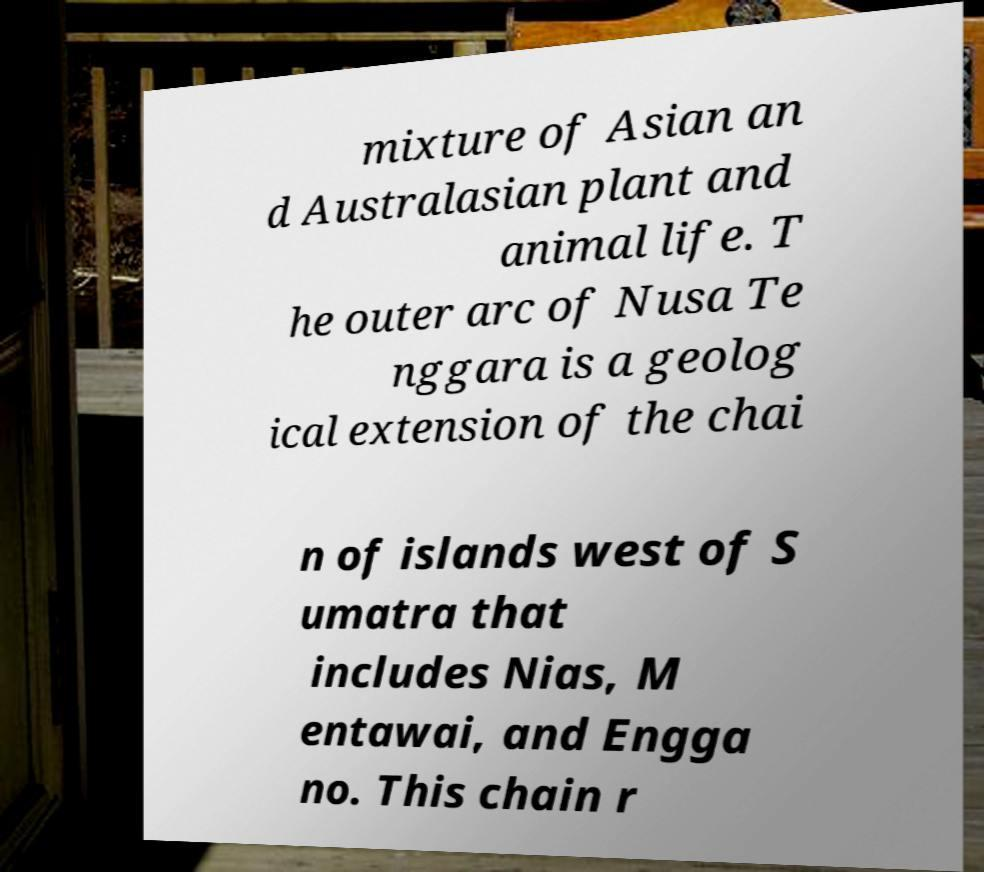For documentation purposes, I need the text within this image transcribed. Could you provide that? mixture of Asian an d Australasian plant and animal life. T he outer arc of Nusa Te nggara is a geolog ical extension of the chai n of islands west of S umatra that includes Nias, M entawai, and Engga no. This chain r 